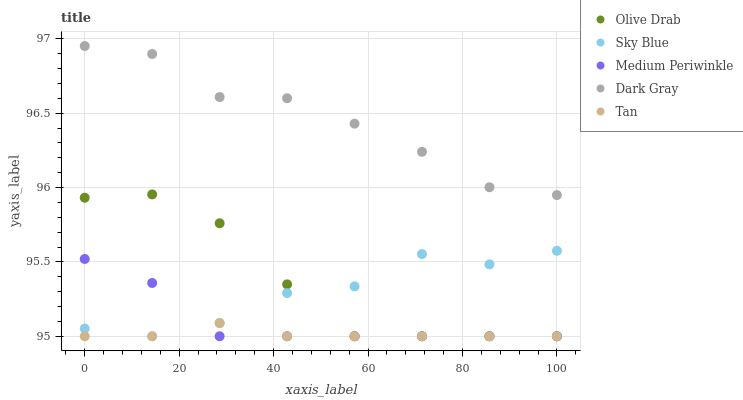Does Tan have the minimum area under the curve?
Answer yes or no. Yes. Does Dark Gray have the maximum area under the curve?
Answer yes or no. Yes. Does Sky Blue have the minimum area under the curve?
Answer yes or no. No. Does Sky Blue have the maximum area under the curve?
Answer yes or no. No. Is Tan the smoothest?
Answer yes or no. Yes. Is Sky Blue the roughest?
Answer yes or no. Yes. Is Sky Blue the smoothest?
Answer yes or no. No. Is Tan the roughest?
Answer yes or no. No. Does Sky Blue have the lowest value?
Answer yes or no. Yes. Does Dark Gray have the highest value?
Answer yes or no. Yes. Does Sky Blue have the highest value?
Answer yes or no. No. Is Sky Blue less than Dark Gray?
Answer yes or no. Yes. Is Dark Gray greater than Medium Periwinkle?
Answer yes or no. Yes. Does Olive Drab intersect Tan?
Answer yes or no. Yes. Is Olive Drab less than Tan?
Answer yes or no. No. Is Olive Drab greater than Tan?
Answer yes or no. No. Does Sky Blue intersect Dark Gray?
Answer yes or no. No. 